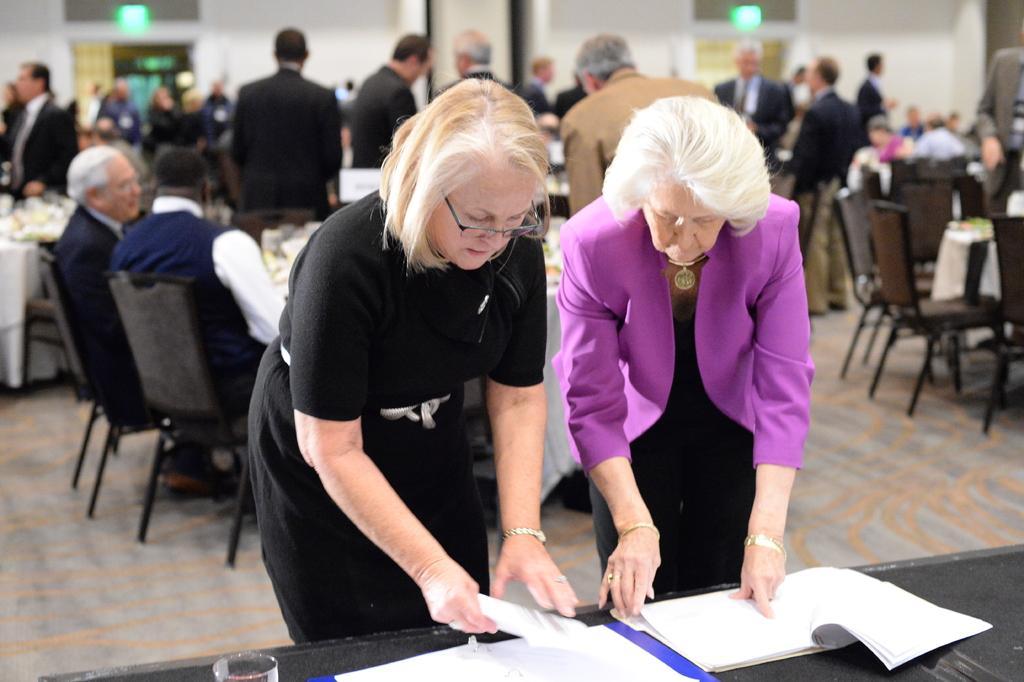Describe this image in one or two sentences. In this image I can see people among them some are standing and some are sitting on chairs in front of tables. On tables I can see some objects. Here I can see book and some other objects on a black color surface. The background of the image is blurred. 